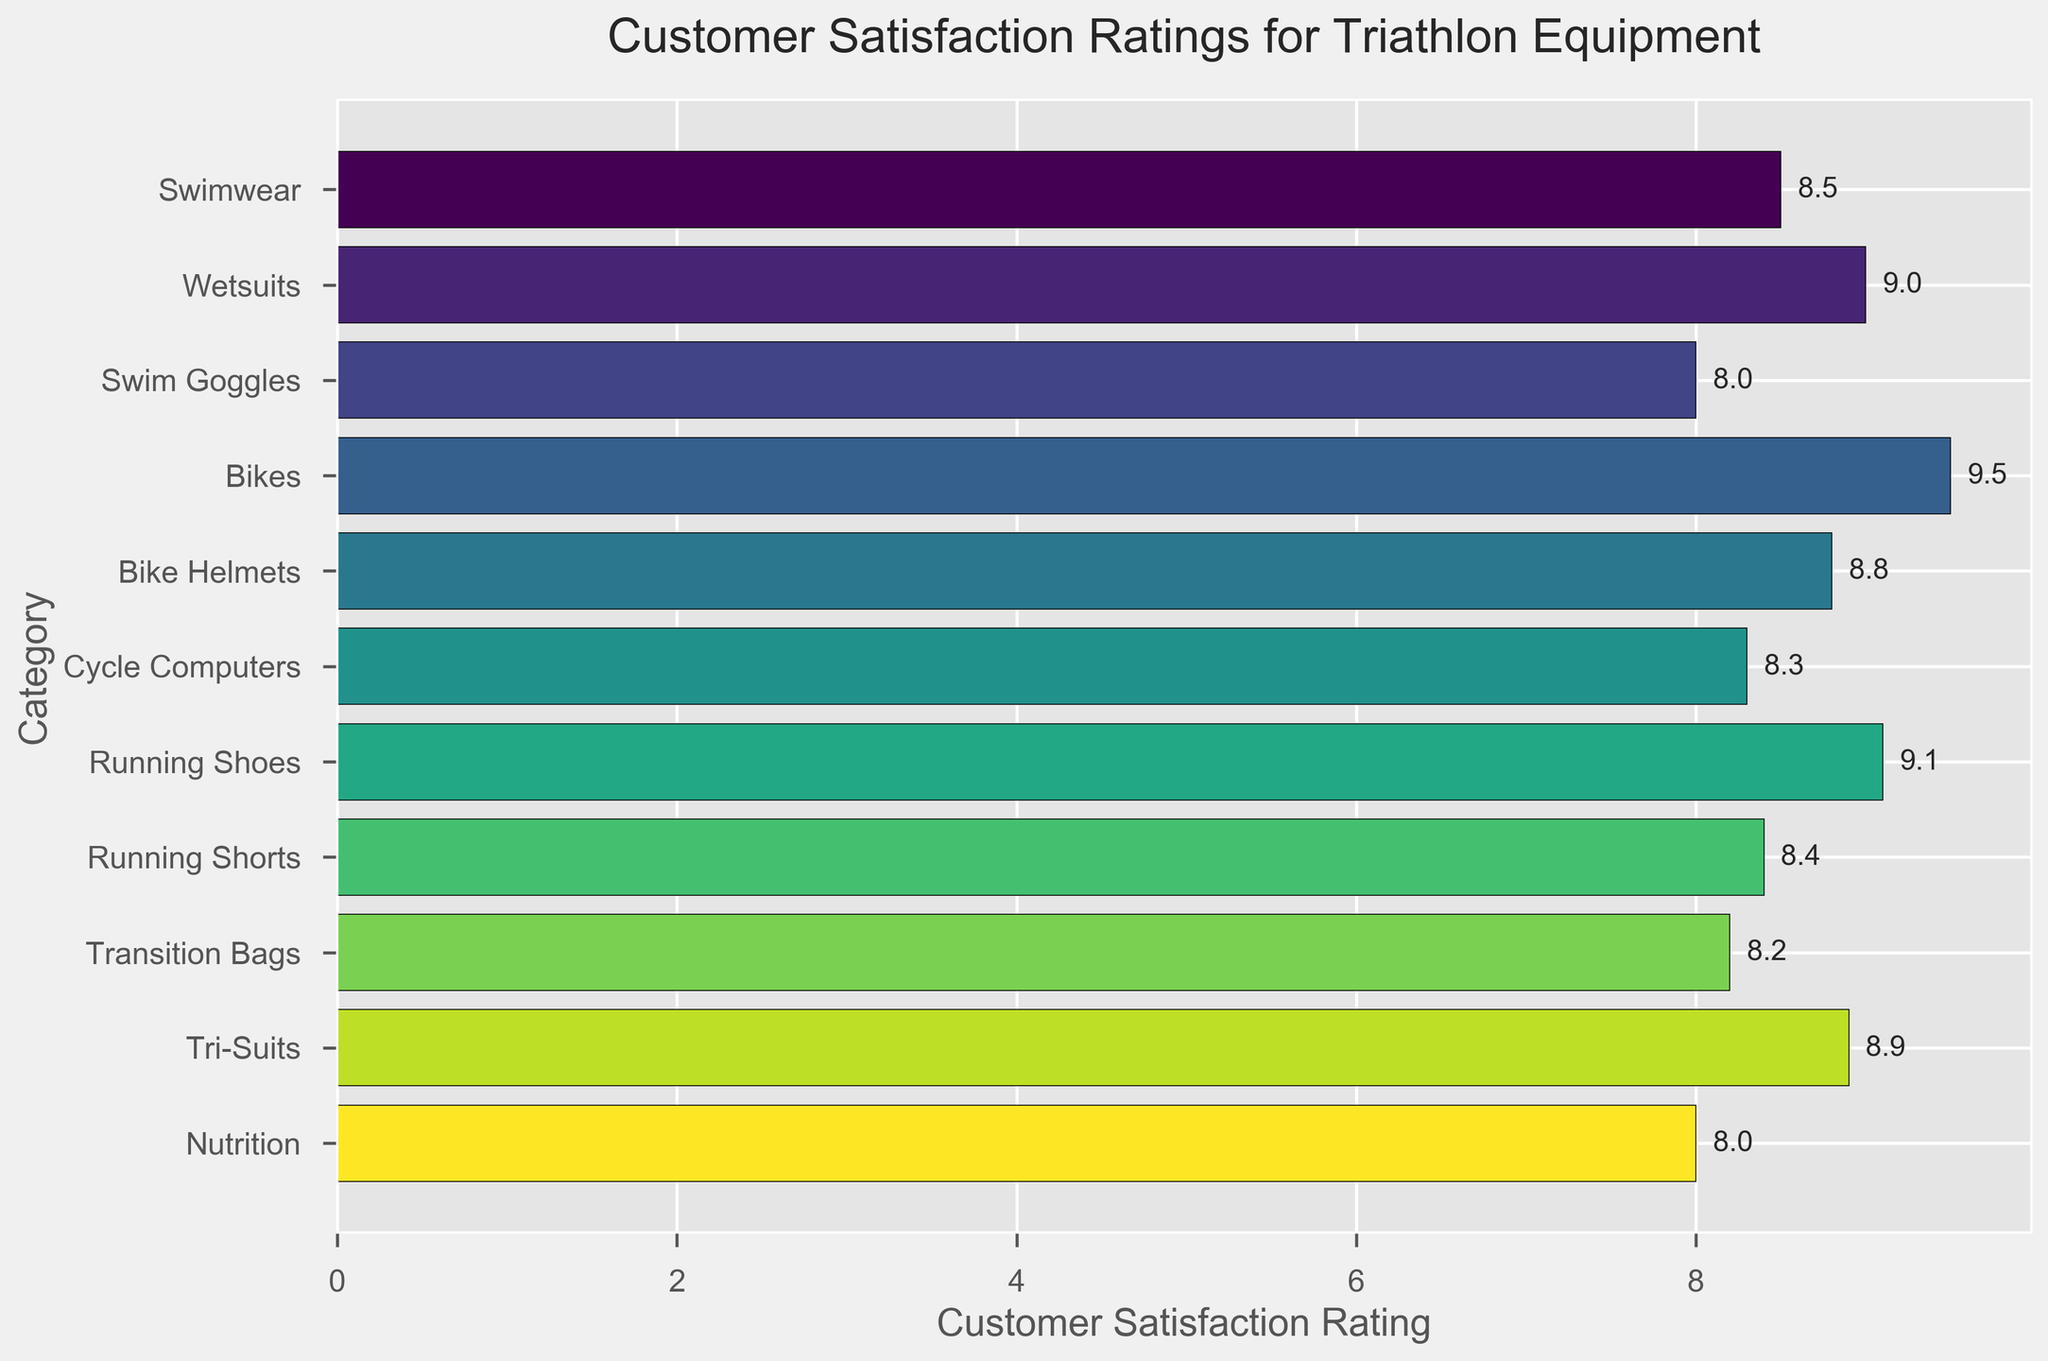What's the highest customer satisfaction rating? The highest customer satisfaction rating is the largest value on the x-axis. By looking at the bars, the highest rating is for Bikes with a rating of 9.5.
Answer: 9.5 What equipment category received the lowest customer satisfaction rating? The lowest rating can be identified by the shortest bar on the graph. Swim Goggles and Nutrition both received the lowest rating with a score of 8.0.
Answer: Swim Goggles and Nutrition How many categories have a customer satisfaction rating of 8.5 or higher? Count the number of bars that extend to the right of the 8.5 mark on the x-axis. Categories with ratings of 8.5 or higher are Swimwear, Wetsuits, Bikes, Bike Helmets, Running Shoes, Running Shorts, and Tri-Suits.
Answer: 7 Which equipment category has a rating exactly equal to 8.9, and what is it? Find the bar that corresponds to 8.9 on the x-axis. The category with this rating is Tri-Suits.
Answer: Tri-Suits, 8.9 Are there more categories with ratings above or below 8.5? Count the number of categories above 8.5 and those below 8.5. There are four categories below 8.5 (Swim Goggles, Cycle Computers, Transition Bags, and Nutrition) and six categories above 8.5, including those at 8.5 (Swimwear, Wetsuits, Bikes, Bike Helmets, Running Shoes, and Tri-Suits).
Answer: Above What is the total customer satisfaction rating when adding up the ratings for Swimwear, Wetsuits, and Swim Goggles? Add the ratings for each category: Swimwear (8.5), Wetsuits (9.0), and Swim Goggles (8.0). The sum is 8.5 + 9.0 + 8.0 = 25.5.
Answer: 25.5 Which category has a higher satisfaction rating: Bike Helmets or Running Shoes? Compare the bar lengths for Bike Helmets and Running Shoes. Bike Helmets have a rating of 8.8 and Running Shoes have a rating of 9.1. Running Shoes have a higher rating.
Answer: Running Shoes What is the average satisfaction rating for Swimwear, Wetsuits, and Tri-Suits? Add the ratings for the three categories and divide by the number of categories. (8.5 + 9.0 + 8.9) / 3 = 26.4 / 3 = 8.8.
Answer: 8.8 Is the satisfaction rating for Transition Bags higher than Cycle Computers? Compare the ratings of the two categories. Transition Bags have a rating of 8.2 and Cycle Computers have a rating of 8.3. Cycle Computers have a higher rating.
Answer: No Which category has the third-highest customer satisfaction rating? Order the categories by their ratings and find the third-highest. The first highest is Bikes (9.5), second is Running Shoes (9.1), and third is Wetsuits (9.0).
Answer: Wetsuits 